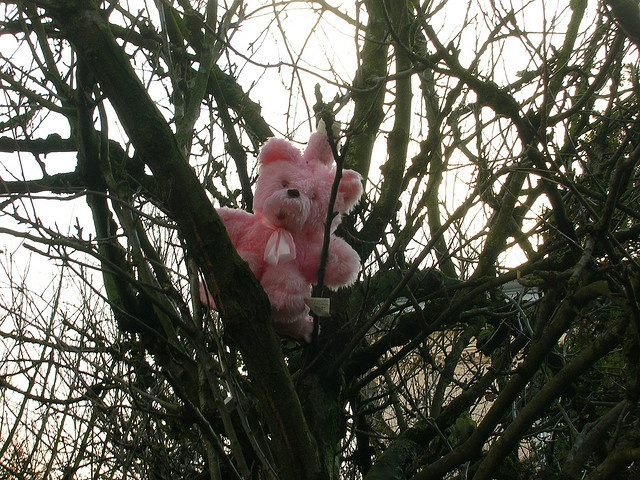Describe the objects in this image and their specific colors. I can see a teddy bear in gray, brown, maroon, and black tones in this image. 